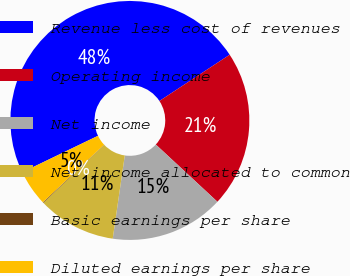Convert chart to OTSL. <chart><loc_0><loc_0><loc_500><loc_500><pie_chart><fcel>Revenue less cost of revenues<fcel>Operating income<fcel>Net income<fcel>Net income allocated to common<fcel>Basic earnings per share<fcel>Diluted earnings per share<nl><fcel>47.88%<fcel>21.18%<fcel>15.38%<fcel>10.6%<fcel>0.09%<fcel>4.87%<nl></chart> 